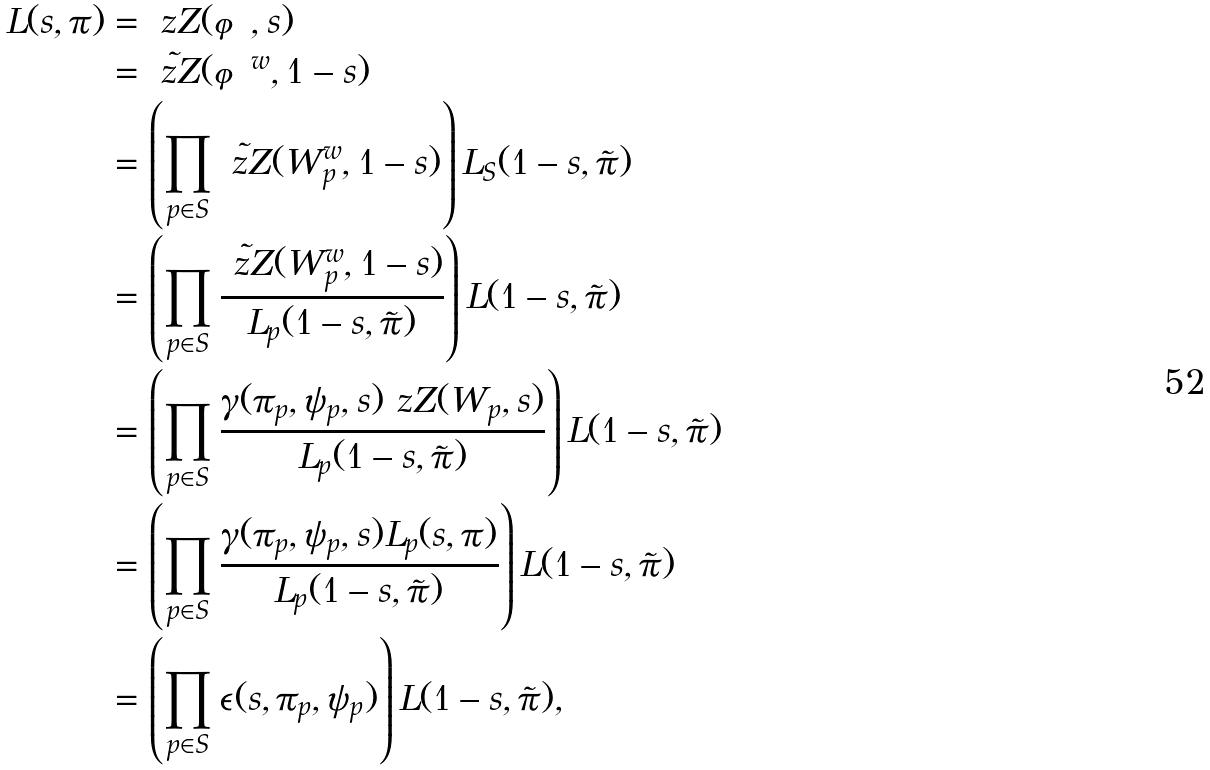Convert formula to latex. <formula><loc_0><loc_0><loc_500><loc_500>L ( s , \pi ) & = \ z Z ( \varphi , s ) \\ & = \tilde { \ z Z } ( \varphi ^ { w } , 1 - s ) \\ & = \left ( \prod _ { p \in S } \tilde { \ z Z } ( W _ { p } ^ { w } , 1 - s ) \right ) L _ { S } ( 1 - s , \tilde { \pi } ) \\ & = \left ( \prod _ { p \in S } \frac { \tilde { \ z Z } ( W _ { p } ^ { w } , 1 - s ) } { L _ { p } ( 1 - s , \tilde { \pi } ) } \right ) L ( 1 - s , \tilde { \pi } ) \\ & = \left ( \prod _ { p \in S } \frac { \gamma ( \pi _ { p } , \psi _ { p } , s ) \ z Z ( W _ { p } , s ) } { L _ { p } ( 1 - s , \tilde { \pi } ) } \right ) L ( 1 - s , \tilde { \pi } ) \\ & = \left ( \prod _ { p \in S } \frac { \gamma ( \pi _ { p } , \psi _ { p } , s ) L _ { p } ( s , \pi ) } { L _ { p } ( 1 - s , \tilde { \pi } ) } \right ) L ( 1 - s , \tilde { \pi } ) \\ & = \left ( \prod _ { p \in S } \epsilon ( s , \pi _ { p } , \psi _ { p } ) \right ) L ( 1 - s , \tilde { \pi } ) ,</formula> 